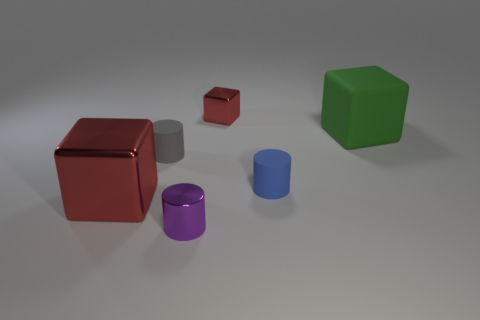Subtract all green balls. How many red blocks are left? 2 Subtract all shiny cylinders. How many cylinders are left? 2 Add 3 green metallic cylinders. How many objects exist? 9 Subtract all cyan cylinders. Subtract all purple blocks. How many cylinders are left? 3 Subtract all small cyan rubber balls. Subtract all tiny blue cylinders. How many objects are left? 5 Add 5 rubber cylinders. How many rubber cylinders are left? 7 Add 2 brown shiny cubes. How many brown shiny cubes exist? 2 Subtract 1 blue cylinders. How many objects are left? 5 